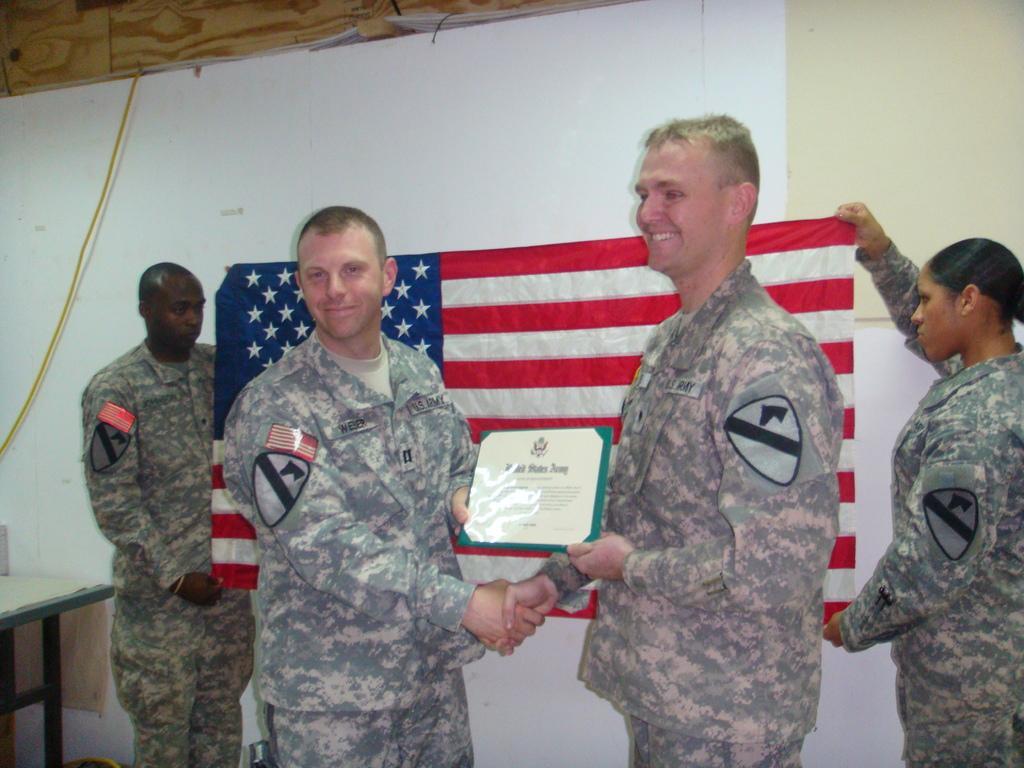Describe this image in one or two sentences. In this image, we can see two persons shaking hands and holding memorandum with their hands. There are other two persons holding a flag with their hands In front of the wall. There is a table in the bottom left of the image. 